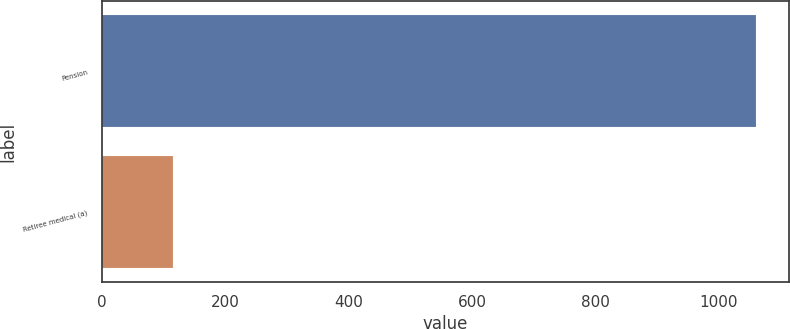Convert chart to OTSL. <chart><loc_0><loc_0><loc_500><loc_500><bar_chart><fcel>Pension<fcel>Retiree medical (a)<nl><fcel>1060<fcel>115<nl></chart> 